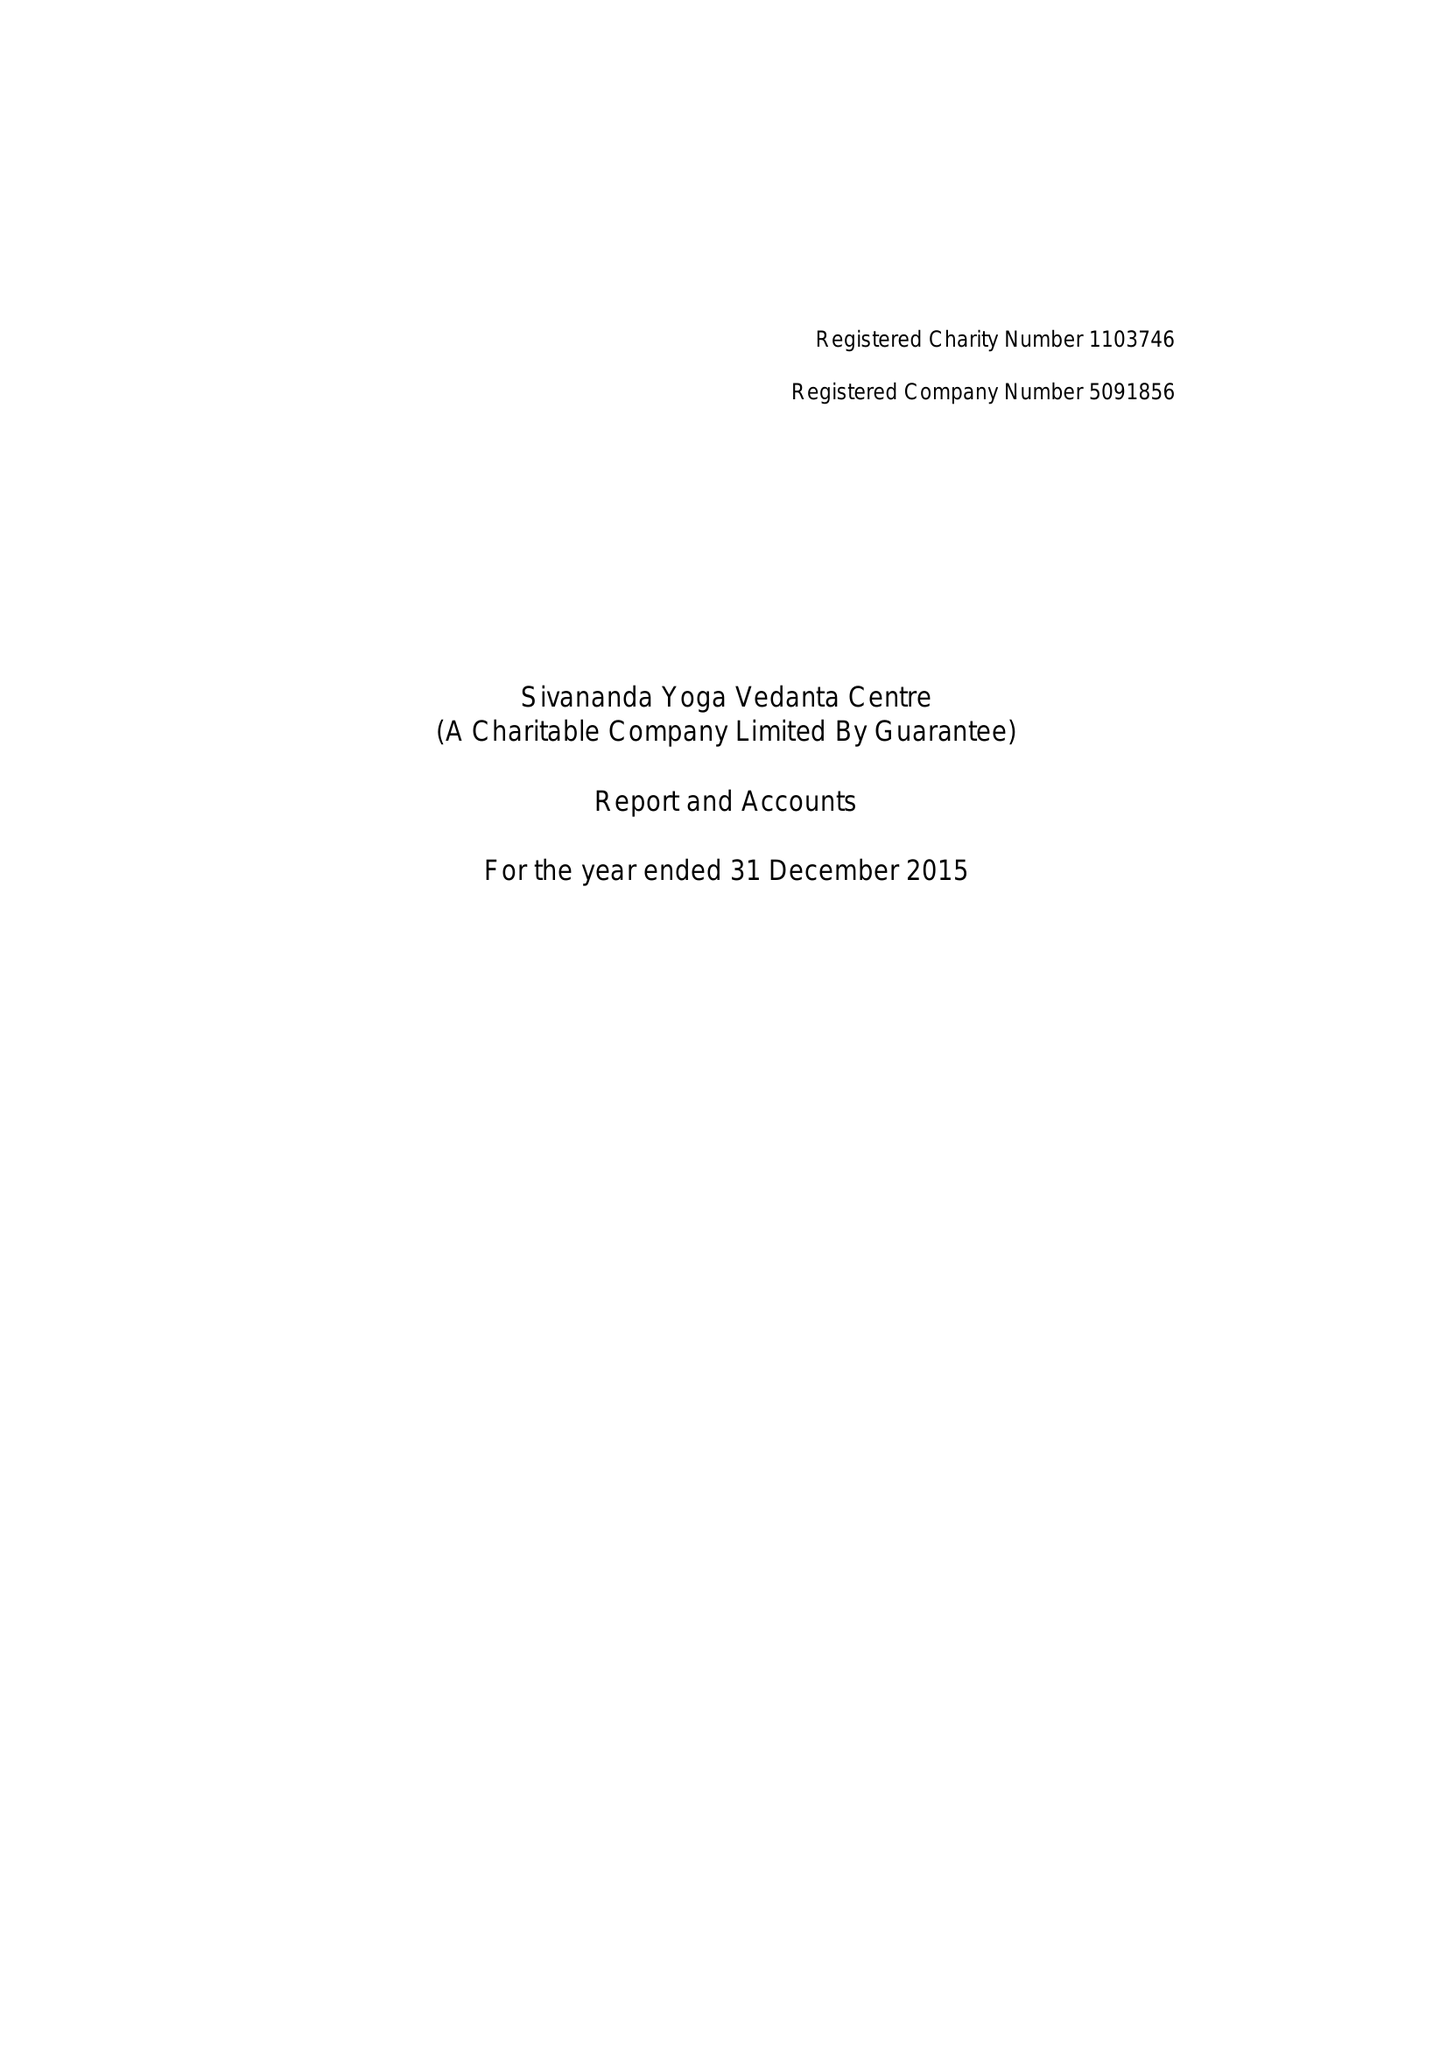What is the value for the income_annually_in_british_pounds?
Answer the question using a single word or phrase. 247608.00 